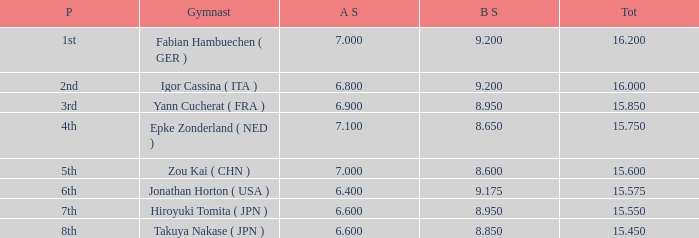What was the total rating that had a score higher than 7 and a b score smaller than 8.65? None. 